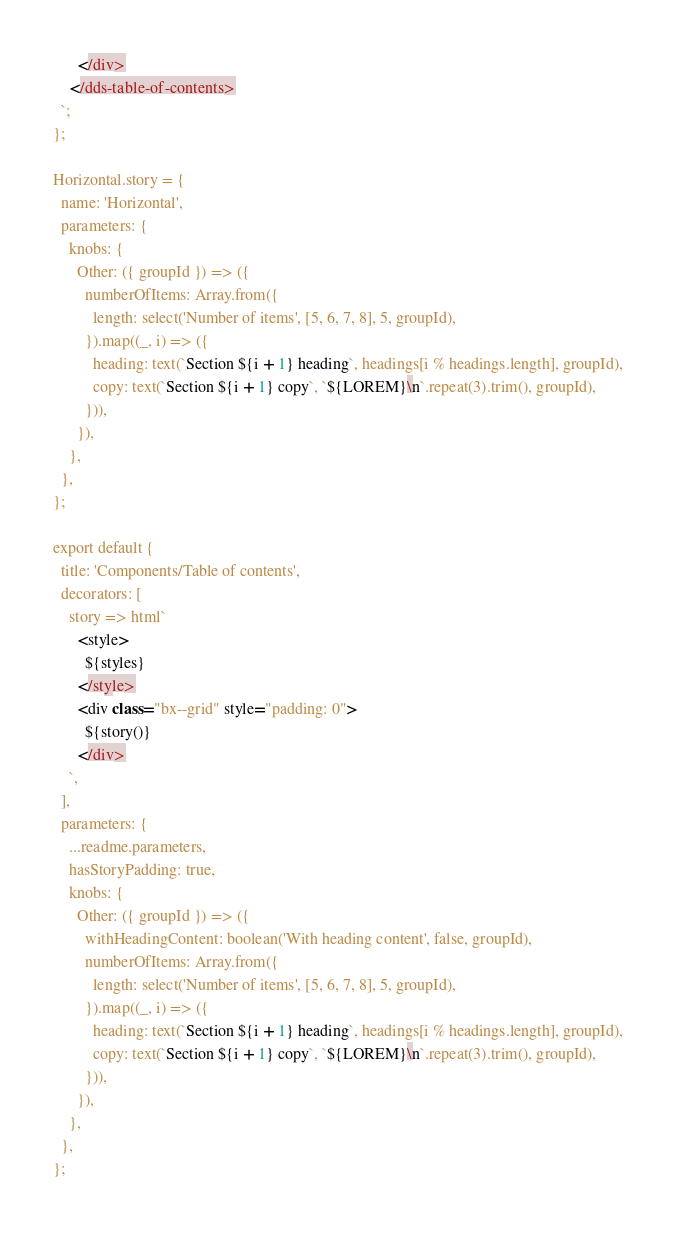<code> <loc_0><loc_0><loc_500><loc_500><_TypeScript_>      </div>
    </dds-table-of-contents>
  `;
};

Horizontal.story = {
  name: 'Horizontal',
  parameters: {
    knobs: {
      Other: ({ groupId }) => ({
        numberOfItems: Array.from({
          length: select('Number of items', [5, 6, 7, 8], 5, groupId),
        }).map((_, i) => ({
          heading: text(`Section ${i + 1} heading`, headings[i % headings.length], groupId),
          copy: text(`Section ${i + 1} copy`, `${LOREM}\n`.repeat(3).trim(), groupId),
        })),
      }),
    },
  },
};

export default {
  title: 'Components/Table of contents',
  decorators: [
    story => html`
      <style>
        ${styles}
      </style>
      <div class="bx--grid" style="padding: 0">
        ${story()}
      </div>
    `,
  ],
  parameters: {
    ...readme.parameters,
    hasStoryPadding: true,
    knobs: {
      Other: ({ groupId }) => ({
        withHeadingContent: boolean('With heading content', false, groupId),
        numberOfItems: Array.from({
          length: select('Number of items', [5, 6, 7, 8], 5, groupId),
        }).map((_, i) => ({
          heading: text(`Section ${i + 1} heading`, headings[i % headings.length], groupId),
          copy: text(`Section ${i + 1} copy`, `${LOREM}\n`.repeat(3).trim(), groupId),
        })),
      }),
    },
  },
};
</code> 